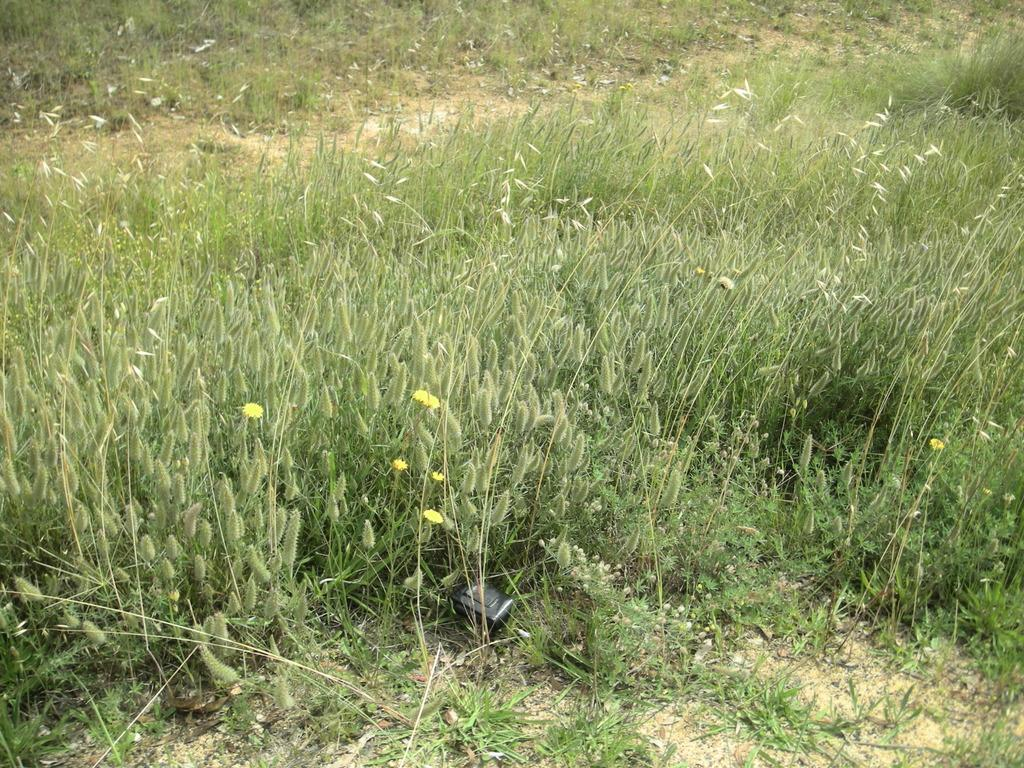What is the black object on the ground in the image? The black object on the ground is not specified in the facts provided. What type of vegetation can be seen in the image? There are flowers and plants with buds in the image. What is the ground covered with in the image? The ground is covered with grass. What type of dress can be seen hanging on the tree in the image? There is no dress present in the image; it features flowers, plants, and buds with grass on the ground. Can you describe the woolen texture of the blanket on the seashore in the image? There is no blanket or seashore present in the image; it features a black object on the ground, flowers, plants, and grass. 